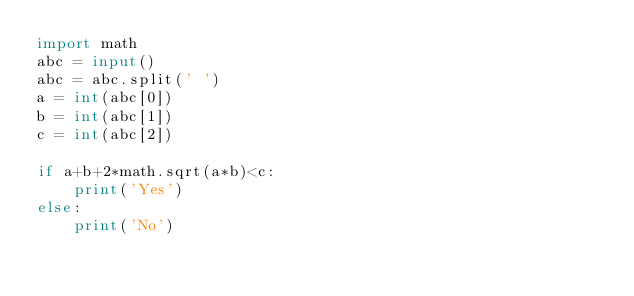<code> <loc_0><loc_0><loc_500><loc_500><_Python_>import math
abc = input()
abc = abc.split(' ')
a = int(abc[0])
b = int(abc[1])
c = int(abc[2])

if a+b+2*math.sqrt(a*b)<c:
    print('Yes')
else:
    print('No')</code> 